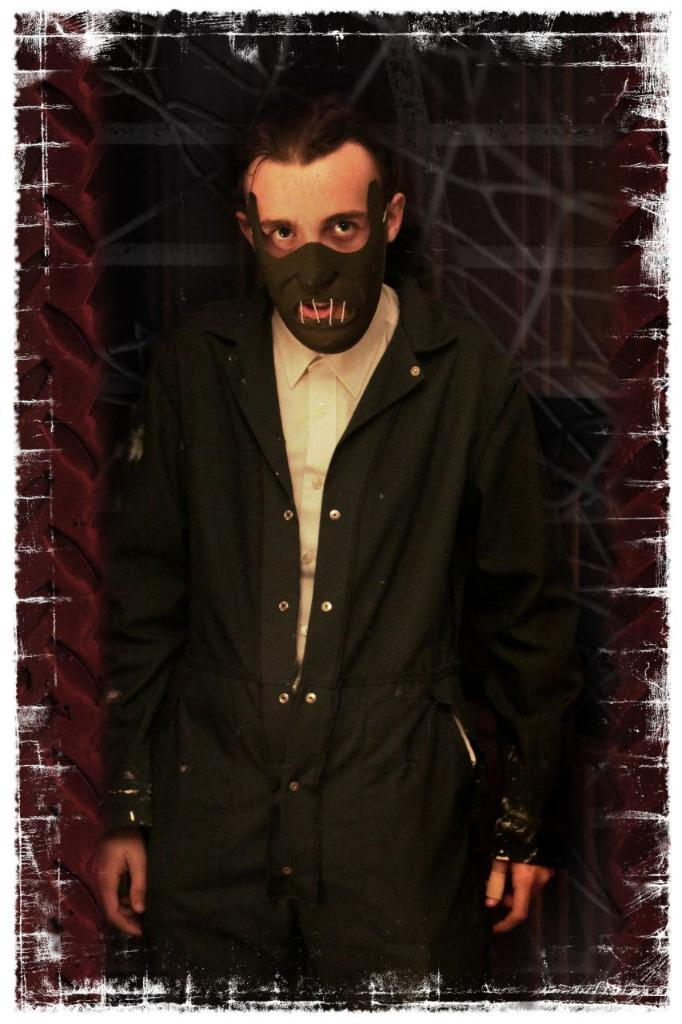Who is present in the image? There is a man in the image. What is the man wearing on his face? The man is wearing a mask. What is the weight of the fact that the man is wearing a mask in the image? The weight of the fact cannot be determined, as it is not a physical object. 